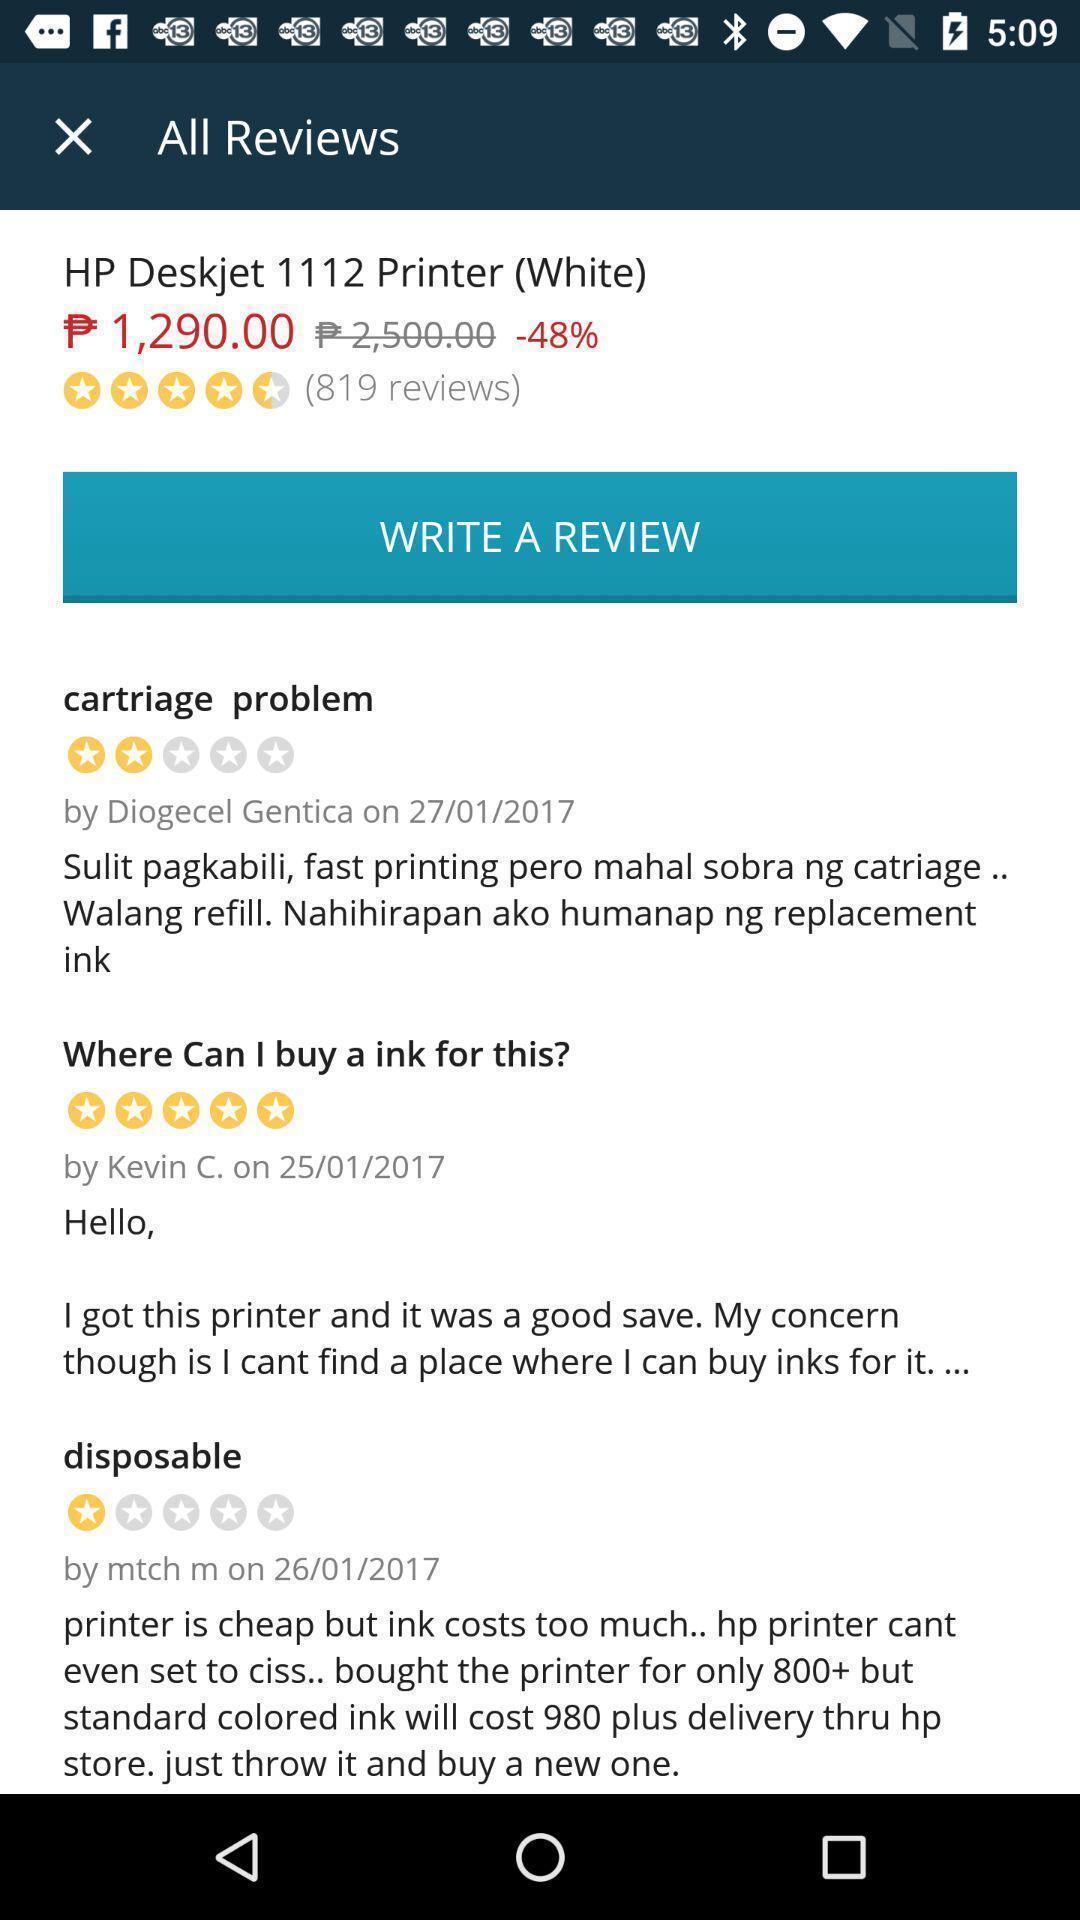Summarize the information in this screenshot. Page showing variety of reviews. 